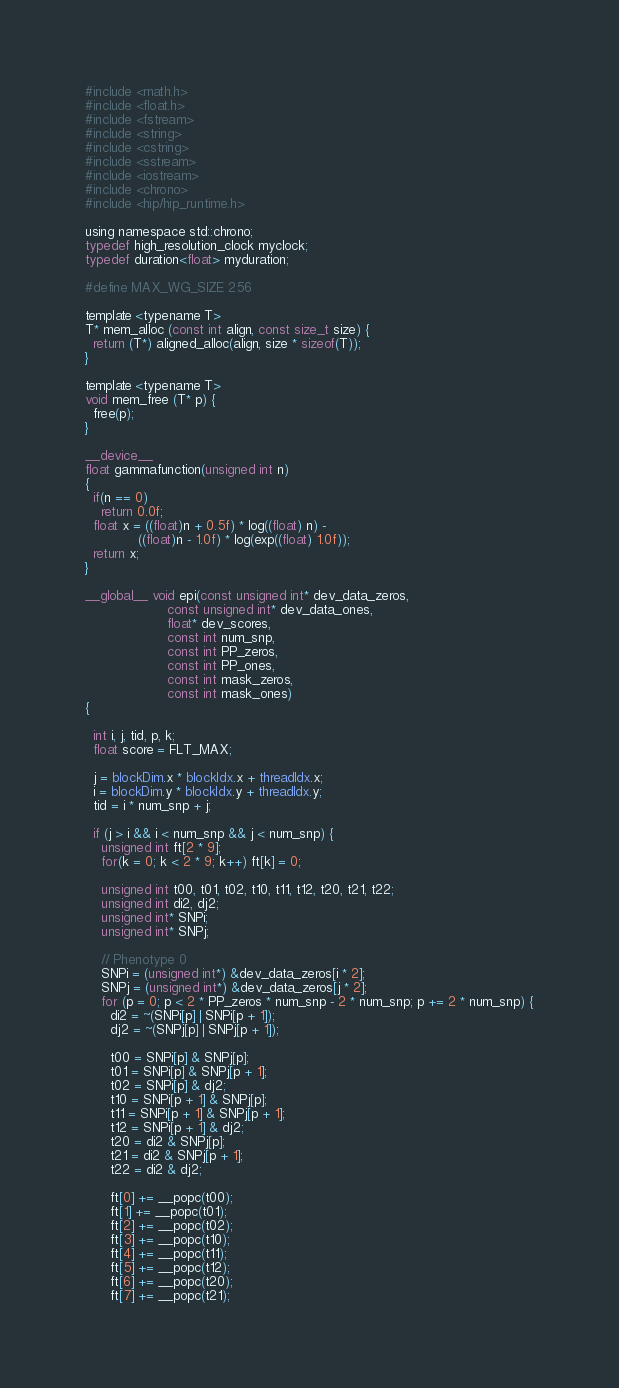Convert code to text. <code><loc_0><loc_0><loc_500><loc_500><_Cuda_>#include <math.h>
#include <float.h>
#include <fstream>
#include <string>
#include <cstring>
#include <sstream>
#include <iostream>
#include <chrono>
#include <hip/hip_runtime.h>

using namespace std::chrono;
typedef high_resolution_clock myclock;
typedef duration<float> myduration;

#define MAX_WG_SIZE 256

template <typename T>
T* mem_alloc (const int align, const size_t size) {
  return (T*) aligned_alloc(align, size * sizeof(T));
}

template <typename T>
void mem_free (T* p) {
  free(p);
}

__device__
float gammafunction(unsigned int n)
{   
  if(n == 0)
    return 0.0f;
  float x = ((float)n + 0.5f) * log((float) n) - 
             ((float)n - 1.0f) * log(exp((float) 1.0f));
  return x;
}

__global__ void epi(const unsigned int* dev_data_zeros, 
                    const unsigned int* dev_data_ones, 
                    float* dev_scores, 
                    const int num_snp, 
                    const int PP_zeros, 
                    const int PP_ones,
                    const int mask_zeros, 
                    const int mask_ones) 
{

  int i, j, tid, p, k;
  float score = FLT_MAX;

  j = blockDim.x * blockIdx.x + threadIdx.x; 
  i = blockDim.y * blockIdx.y + threadIdx.y;
  tid = i * num_snp + j;

  if (j > i && i < num_snp && j < num_snp) {
    unsigned int ft[2 * 9];
    for(k = 0; k < 2 * 9; k++) ft[k] = 0;

    unsigned int t00, t01, t02, t10, t11, t12, t20, t21, t22;
    unsigned int di2, dj2;
    unsigned int* SNPi;
    unsigned int* SNPj;

    // Phenotype 0
    SNPi = (unsigned int*) &dev_data_zeros[i * 2];
    SNPj = (unsigned int*) &dev_data_zeros[j * 2];
    for (p = 0; p < 2 * PP_zeros * num_snp - 2 * num_snp; p += 2 * num_snp) {
      di2 = ~(SNPi[p] | SNPi[p + 1]);
      dj2 = ~(SNPj[p] | SNPj[p + 1]);

      t00 = SNPi[p] & SNPj[p];
      t01 = SNPi[p] & SNPj[p + 1];
      t02 = SNPi[p] & dj2;
      t10 = SNPi[p + 1] & SNPj[p];
      t11 = SNPi[p + 1] & SNPj[p + 1];
      t12 = SNPi[p + 1] & dj2;
      t20 = di2 & SNPj[p];
      t21 = di2 & SNPj[p + 1];
      t22 = di2 & dj2;

      ft[0] += __popc(t00);
      ft[1] += __popc(t01);
      ft[2] += __popc(t02);
      ft[3] += __popc(t10);
      ft[4] += __popc(t11);
      ft[5] += __popc(t12);
      ft[6] += __popc(t20);
      ft[7] += __popc(t21);</code> 